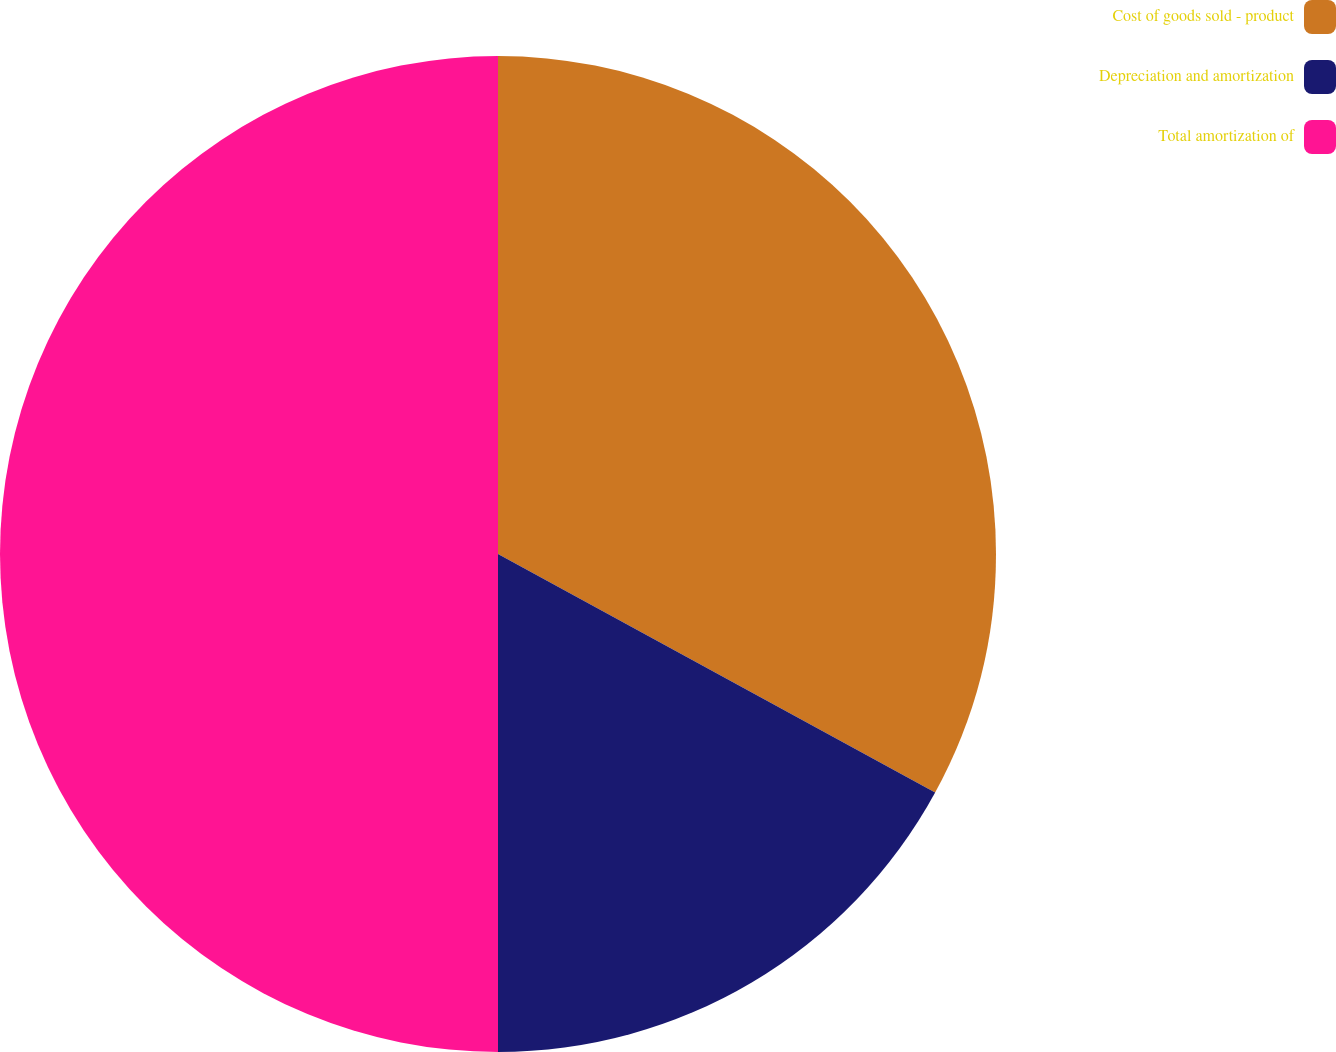Convert chart to OTSL. <chart><loc_0><loc_0><loc_500><loc_500><pie_chart><fcel>Cost of goods sold - product<fcel>Depreciation and amortization<fcel>Total amortization of<nl><fcel>32.95%<fcel>17.05%<fcel>50.0%<nl></chart> 